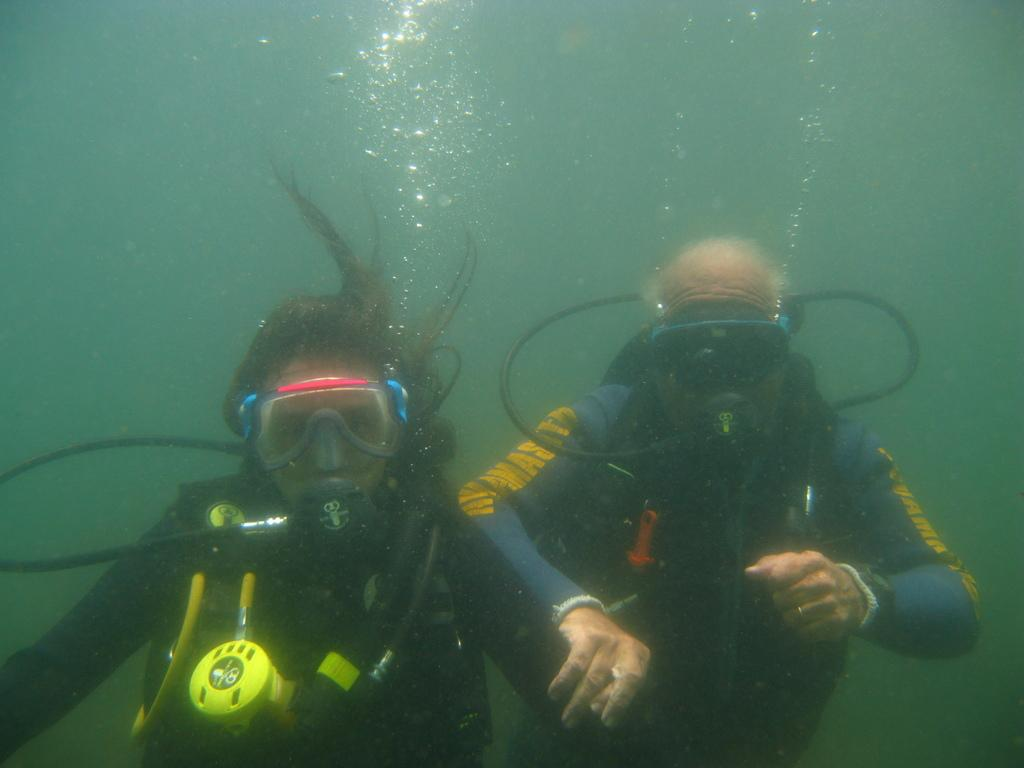How many people are in the image? There are two people in the image, a man and a woman. What are the man and woman wearing in the image? Both the man and woman are wearing scuba diving suits in the image. What can be observed about their eyes in the image? Both the man and woman are wearing spectacles in the image. Where are the man and woman located in the image? They are underwater in the image. What type of magic trick is the man performing with the plate in the image? There is no plate or magic trick present in the image; it features a man and a woman wearing scuba diving suits and spectacles underwater. How many dolls are visible in the image? There are no dolls present in the image. 